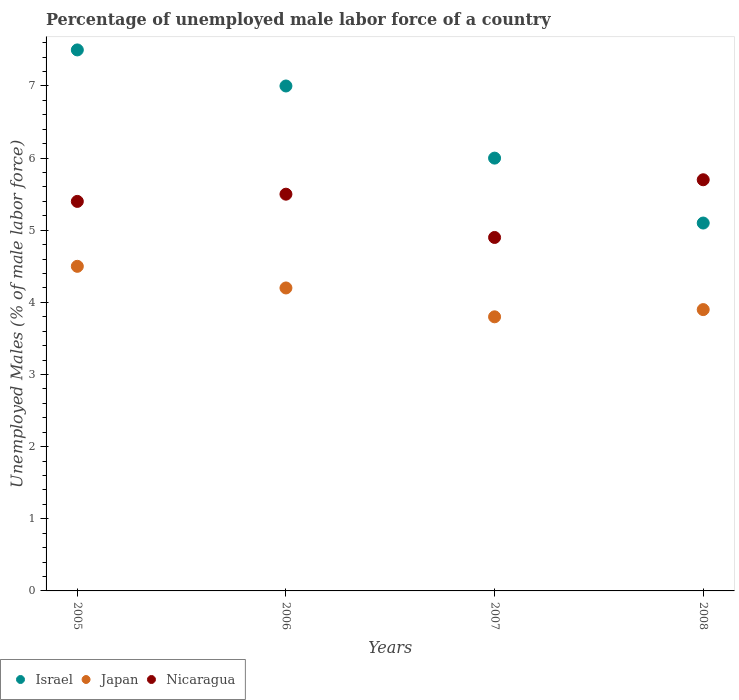Across all years, what is the maximum percentage of unemployed male labor force in Israel?
Ensure brevity in your answer.  7.5. Across all years, what is the minimum percentage of unemployed male labor force in Israel?
Provide a short and direct response. 5.1. In which year was the percentage of unemployed male labor force in Japan maximum?
Give a very brief answer. 2005. In which year was the percentage of unemployed male labor force in Japan minimum?
Provide a succinct answer. 2007. What is the total percentage of unemployed male labor force in Japan in the graph?
Your response must be concise. 16.4. What is the difference between the percentage of unemployed male labor force in Israel in 2005 and that in 2006?
Offer a very short reply. 0.5. What is the difference between the percentage of unemployed male labor force in Japan in 2006 and the percentage of unemployed male labor force in Nicaragua in 2008?
Provide a succinct answer. -1.5. What is the average percentage of unemployed male labor force in Nicaragua per year?
Provide a succinct answer. 5.37. In the year 2007, what is the difference between the percentage of unemployed male labor force in Israel and percentage of unemployed male labor force in Nicaragua?
Your answer should be very brief. 1.1. In how many years, is the percentage of unemployed male labor force in Israel greater than 4.4 %?
Give a very brief answer. 4. What is the ratio of the percentage of unemployed male labor force in Japan in 2005 to that in 2008?
Your response must be concise. 1.15. Is the percentage of unemployed male labor force in Israel in 2006 less than that in 2008?
Offer a terse response. No. Is the difference between the percentage of unemployed male labor force in Israel in 2005 and 2008 greater than the difference between the percentage of unemployed male labor force in Nicaragua in 2005 and 2008?
Provide a short and direct response. Yes. What is the difference between the highest and the second highest percentage of unemployed male labor force in Japan?
Offer a terse response. 0.3. What is the difference between the highest and the lowest percentage of unemployed male labor force in Israel?
Give a very brief answer. 2.4. In how many years, is the percentage of unemployed male labor force in Israel greater than the average percentage of unemployed male labor force in Israel taken over all years?
Ensure brevity in your answer.  2. Is the percentage of unemployed male labor force in Nicaragua strictly less than the percentage of unemployed male labor force in Japan over the years?
Your answer should be compact. No. How many years are there in the graph?
Provide a short and direct response. 4. What is the difference between two consecutive major ticks on the Y-axis?
Your answer should be compact. 1. Where does the legend appear in the graph?
Offer a very short reply. Bottom left. How many legend labels are there?
Your response must be concise. 3. What is the title of the graph?
Provide a succinct answer. Percentage of unemployed male labor force of a country. What is the label or title of the X-axis?
Keep it short and to the point. Years. What is the label or title of the Y-axis?
Ensure brevity in your answer.  Unemployed Males (% of male labor force). What is the Unemployed Males (% of male labor force) of Israel in 2005?
Give a very brief answer. 7.5. What is the Unemployed Males (% of male labor force) of Japan in 2005?
Your answer should be very brief. 4.5. What is the Unemployed Males (% of male labor force) in Nicaragua in 2005?
Your answer should be compact. 5.4. What is the Unemployed Males (% of male labor force) in Israel in 2006?
Your answer should be very brief. 7. What is the Unemployed Males (% of male labor force) in Japan in 2006?
Your answer should be compact. 4.2. What is the Unemployed Males (% of male labor force) of Nicaragua in 2006?
Keep it short and to the point. 5.5. What is the Unemployed Males (% of male labor force) in Israel in 2007?
Ensure brevity in your answer.  6. What is the Unemployed Males (% of male labor force) in Japan in 2007?
Your answer should be very brief. 3.8. What is the Unemployed Males (% of male labor force) in Nicaragua in 2007?
Make the answer very short. 4.9. What is the Unemployed Males (% of male labor force) in Israel in 2008?
Make the answer very short. 5.1. What is the Unemployed Males (% of male labor force) of Japan in 2008?
Ensure brevity in your answer.  3.9. What is the Unemployed Males (% of male labor force) of Nicaragua in 2008?
Keep it short and to the point. 5.7. Across all years, what is the maximum Unemployed Males (% of male labor force) in Israel?
Make the answer very short. 7.5. Across all years, what is the maximum Unemployed Males (% of male labor force) of Nicaragua?
Provide a short and direct response. 5.7. Across all years, what is the minimum Unemployed Males (% of male labor force) in Israel?
Offer a terse response. 5.1. Across all years, what is the minimum Unemployed Males (% of male labor force) of Japan?
Offer a very short reply. 3.8. Across all years, what is the minimum Unemployed Males (% of male labor force) of Nicaragua?
Make the answer very short. 4.9. What is the total Unemployed Males (% of male labor force) in Israel in the graph?
Provide a short and direct response. 25.6. What is the total Unemployed Males (% of male labor force) of Japan in the graph?
Your response must be concise. 16.4. What is the total Unemployed Males (% of male labor force) in Nicaragua in the graph?
Ensure brevity in your answer.  21.5. What is the difference between the Unemployed Males (% of male labor force) in Israel in 2005 and that in 2006?
Offer a terse response. 0.5. What is the difference between the Unemployed Males (% of male labor force) of Japan in 2005 and that in 2006?
Keep it short and to the point. 0.3. What is the difference between the Unemployed Males (% of male labor force) of Nicaragua in 2005 and that in 2007?
Give a very brief answer. 0.5. What is the difference between the Unemployed Males (% of male labor force) in Israel in 2005 and that in 2008?
Provide a short and direct response. 2.4. What is the difference between the Unemployed Males (% of male labor force) of Israel in 2006 and that in 2007?
Provide a short and direct response. 1. What is the difference between the Unemployed Males (% of male labor force) in Nicaragua in 2006 and that in 2007?
Offer a very short reply. 0.6. What is the difference between the Unemployed Males (% of male labor force) in Israel in 2006 and that in 2008?
Offer a very short reply. 1.9. What is the difference between the Unemployed Males (% of male labor force) in Japan in 2006 and that in 2008?
Give a very brief answer. 0.3. What is the difference between the Unemployed Males (% of male labor force) of Nicaragua in 2006 and that in 2008?
Provide a short and direct response. -0.2. What is the difference between the Unemployed Males (% of male labor force) in Japan in 2007 and that in 2008?
Your answer should be very brief. -0.1. What is the difference between the Unemployed Males (% of male labor force) in Nicaragua in 2007 and that in 2008?
Your answer should be very brief. -0.8. What is the difference between the Unemployed Males (% of male labor force) of Israel in 2005 and the Unemployed Males (% of male labor force) of Japan in 2006?
Offer a very short reply. 3.3. What is the difference between the Unemployed Males (% of male labor force) in Japan in 2005 and the Unemployed Males (% of male labor force) in Nicaragua in 2006?
Keep it short and to the point. -1. What is the difference between the Unemployed Males (% of male labor force) in Israel in 2005 and the Unemployed Males (% of male labor force) in Nicaragua in 2007?
Your answer should be compact. 2.6. What is the difference between the Unemployed Males (% of male labor force) in Japan in 2005 and the Unemployed Males (% of male labor force) in Nicaragua in 2008?
Provide a short and direct response. -1.2. What is the difference between the Unemployed Males (% of male labor force) of Israel in 2006 and the Unemployed Males (% of male labor force) of Nicaragua in 2008?
Give a very brief answer. 1.3. What is the difference between the Unemployed Males (% of male labor force) of Israel in 2007 and the Unemployed Males (% of male labor force) of Japan in 2008?
Provide a short and direct response. 2.1. What is the average Unemployed Males (% of male labor force) of Israel per year?
Ensure brevity in your answer.  6.4. What is the average Unemployed Males (% of male labor force) in Nicaragua per year?
Your answer should be very brief. 5.38. In the year 2005, what is the difference between the Unemployed Males (% of male labor force) in Japan and Unemployed Males (% of male labor force) in Nicaragua?
Provide a short and direct response. -0.9. In the year 2006, what is the difference between the Unemployed Males (% of male labor force) of Japan and Unemployed Males (% of male labor force) of Nicaragua?
Offer a very short reply. -1.3. What is the ratio of the Unemployed Males (% of male labor force) of Israel in 2005 to that in 2006?
Keep it short and to the point. 1.07. What is the ratio of the Unemployed Males (% of male labor force) in Japan in 2005 to that in 2006?
Provide a succinct answer. 1.07. What is the ratio of the Unemployed Males (% of male labor force) of Nicaragua in 2005 to that in 2006?
Your answer should be very brief. 0.98. What is the ratio of the Unemployed Males (% of male labor force) in Japan in 2005 to that in 2007?
Keep it short and to the point. 1.18. What is the ratio of the Unemployed Males (% of male labor force) of Nicaragua in 2005 to that in 2007?
Ensure brevity in your answer.  1.1. What is the ratio of the Unemployed Males (% of male labor force) of Israel in 2005 to that in 2008?
Your answer should be very brief. 1.47. What is the ratio of the Unemployed Males (% of male labor force) of Japan in 2005 to that in 2008?
Your answer should be very brief. 1.15. What is the ratio of the Unemployed Males (% of male labor force) in Nicaragua in 2005 to that in 2008?
Your response must be concise. 0.95. What is the ratio of the Unemployed Males (% of male labor force) of Japan in 2006 to that in 2007?
Give a very brief answer. 1.11. What is the ratio of the Unemployed Males (% of male labor force) in Nicaragua in 2006 to that in 2007?
Your response must be concise. 1.12. What is the ratio of the Unemployed Males (% of male labor force) of Israel in 2006 to that in 2008?
Provide a short and direct response. 1.37. What is the ratio of the Unemployed Males (% of male labor force) of Japan in 2006 to that in 2008?
Provide a short and direct response. 1.08. What is the ratio of the Unemployed Males (% of male labor force) of Nicaragua in 2006 to that in 2008?
Your answer should be very brief. 0.96. What is the ratio of the Unemployed Males (% of male labor force) of Israel in 2007 to that in 2008?
Your answer should be very brief. 1.18. What is the ratio of the Unemployed Males (% of male labor force) in Japan in 2007 to that in 2008?
Your answer should be very brief. 0.97. What is the ratio of the Unemployed Males (% of male labor force) in Nicaragua in 2007 to that in 2008?
Offer a terse response. 0.86. What is the difference between the highest and the second highest Unemployed Males (% of male labor force) of Israel?
Your answer should be compact. 0.5. What is the difference between the highest and the second highest Unemployed Males (% of male labor force) of Nicaragua?
Offer a terse response. 0.2. 